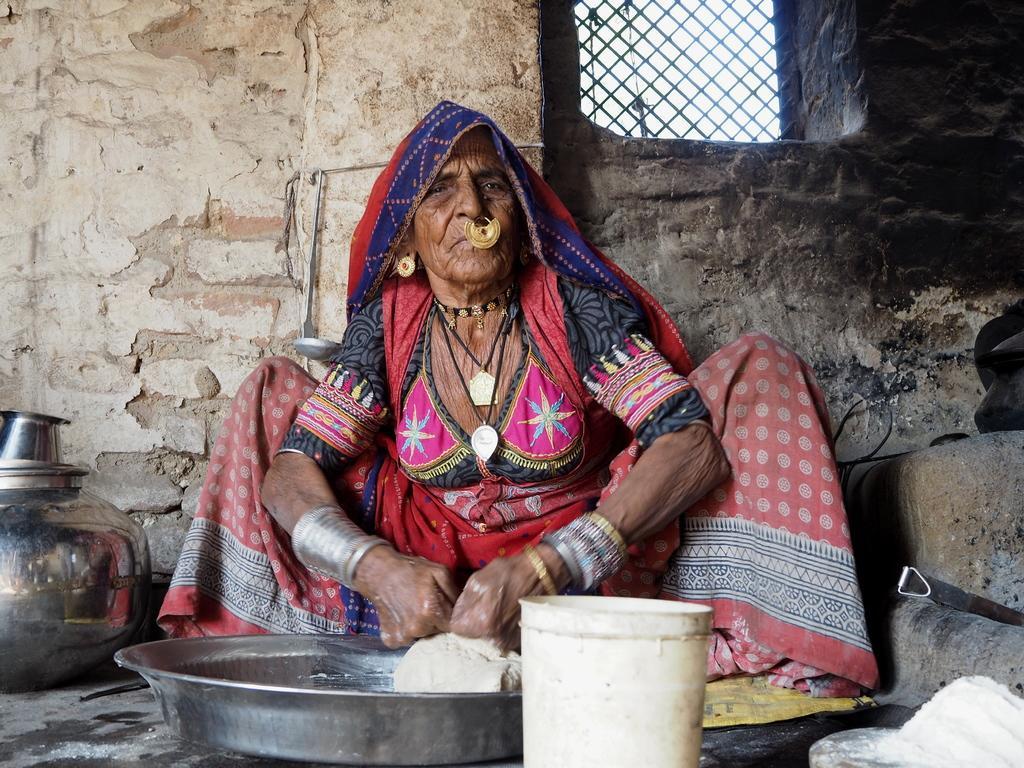How would you summarize this image in a sentence or two? In the image in the center, we can see one woman sitting. In front of her, there are a steel basket, bucket and some food items. In the background there is a wall, window, mug and container. 